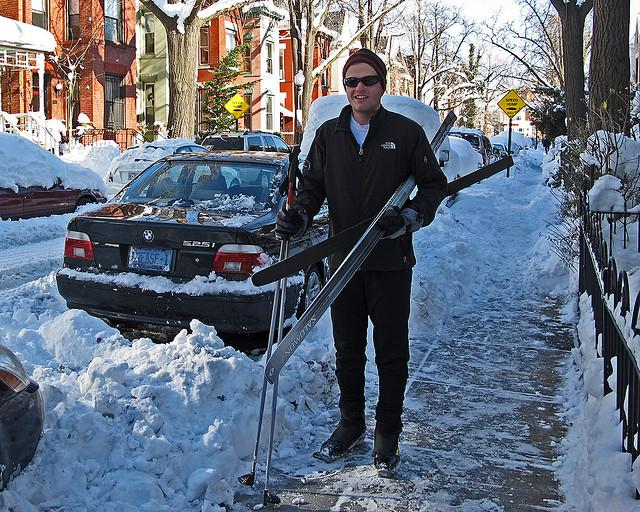How did this man get to this location immediately prior to taking this picture? skis 